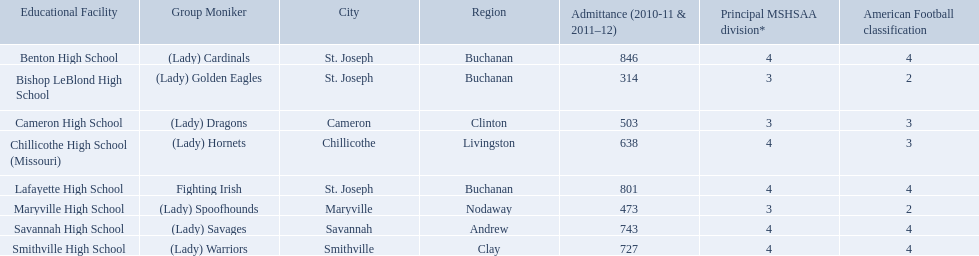What schools are located in st. joseph? Benton High School, Bishop LeBlond High School, Lafayette High School. Which st. joseph schools have more then 800 enrollment  for 2010-11 7 2011-12? Benton High School, Lafayette High School. What is the name of the st. joseph school with 800 or more enrollment's team names is a not a (lady)? Lafayette High School. What were the schools enrolled in 2010-2011 Benton High School, Bishop LeBlond High School, Cameron High School, Chillicothe High School (Missouri), Lafayette High School, Maryville High School, Savannah High School, Smithville High School. How many were enrolled in each? 846, 314, 503, 638, 801, 473, 743, 727. Which is the lowest number? 314. Which school had this number of students? Bishop LeBlond High School. 